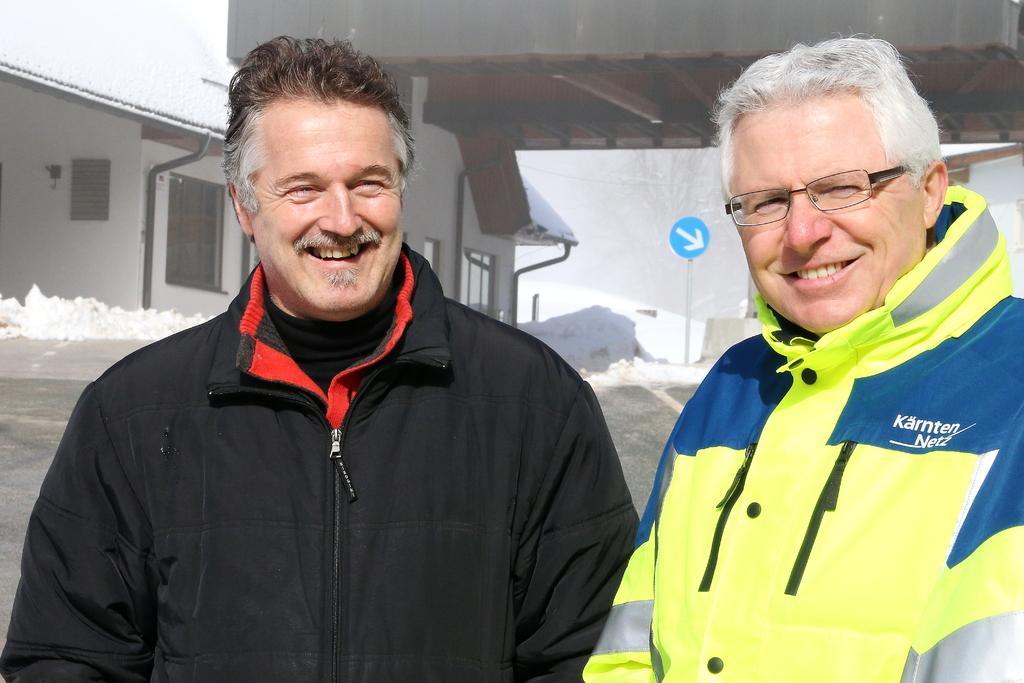Please provide a concise description of this image. In this picture I can see two men are wearing jackets. These men are smiling. The man on the right side is wearing spectacles. The man on the left side is wearing black color jacket. In the background I can see snow, a sign board and a building. 